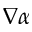Convert formula to latex. <formula><loc_0><loc_0><loc_500><loc_500>\nabla \alpha</formula> 